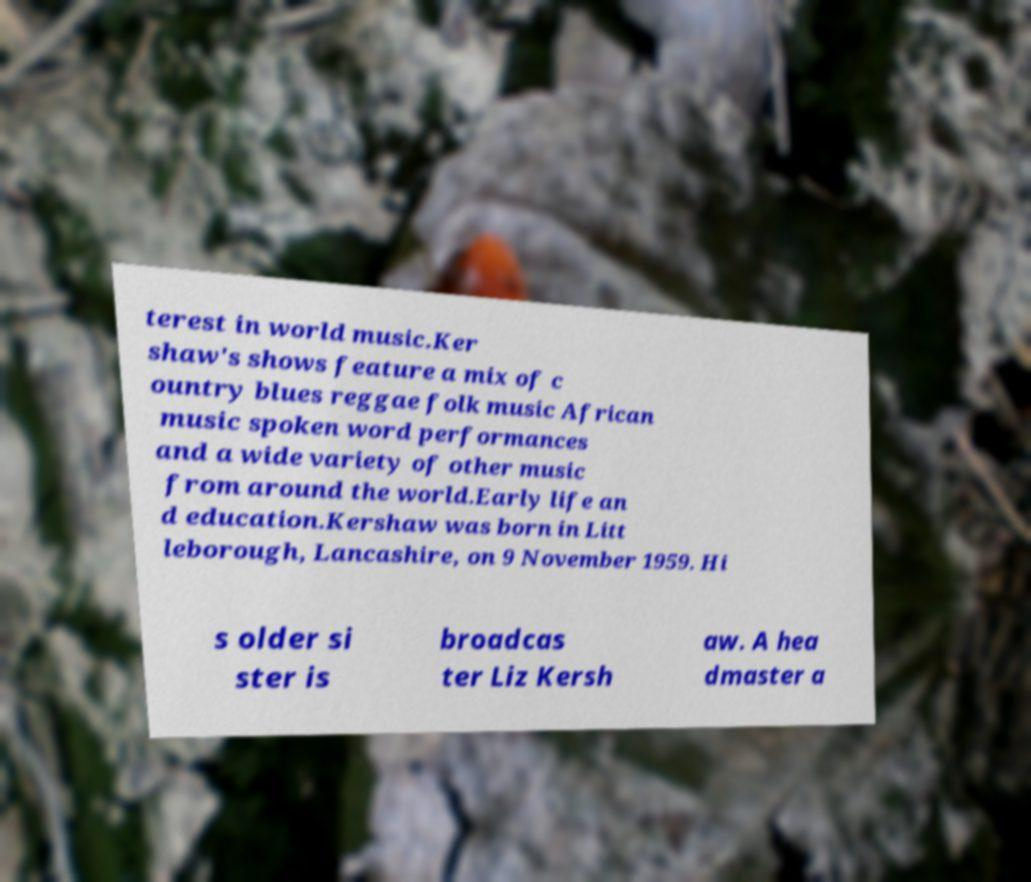What messages or text are displayed in this image? I need them in a readable, typed format. terest in world music.Ker shaw's shows feature a mix of c ountry blues reggae folk music African music spoken word performances and a wide variety of other music from around the world.Early life an d education.Kershaw was born in Litt leborough, Lancashire, on 9 November 1959. Hi s older si ster is broadcas ter Liz Kersh aw. A hea dmaster a 